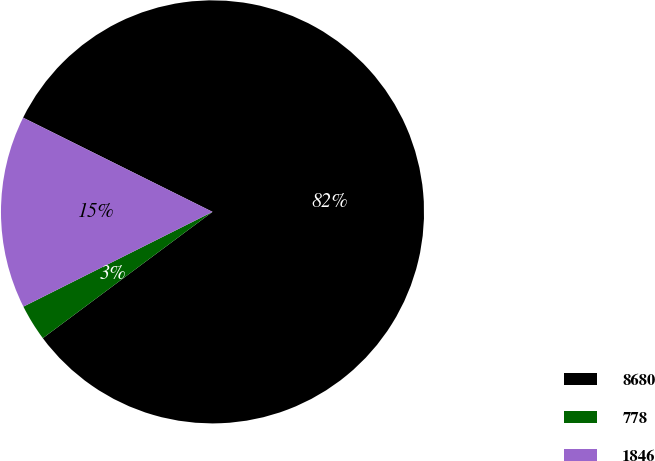<chart> <loc_0><loc_0><loc_500><loc_500><pie_chart><fcel>8680<fcel>778<fcel>1846<nl><fcel>82.47%<fcel>2.79%<fcel>14.74%<nl></chart> 